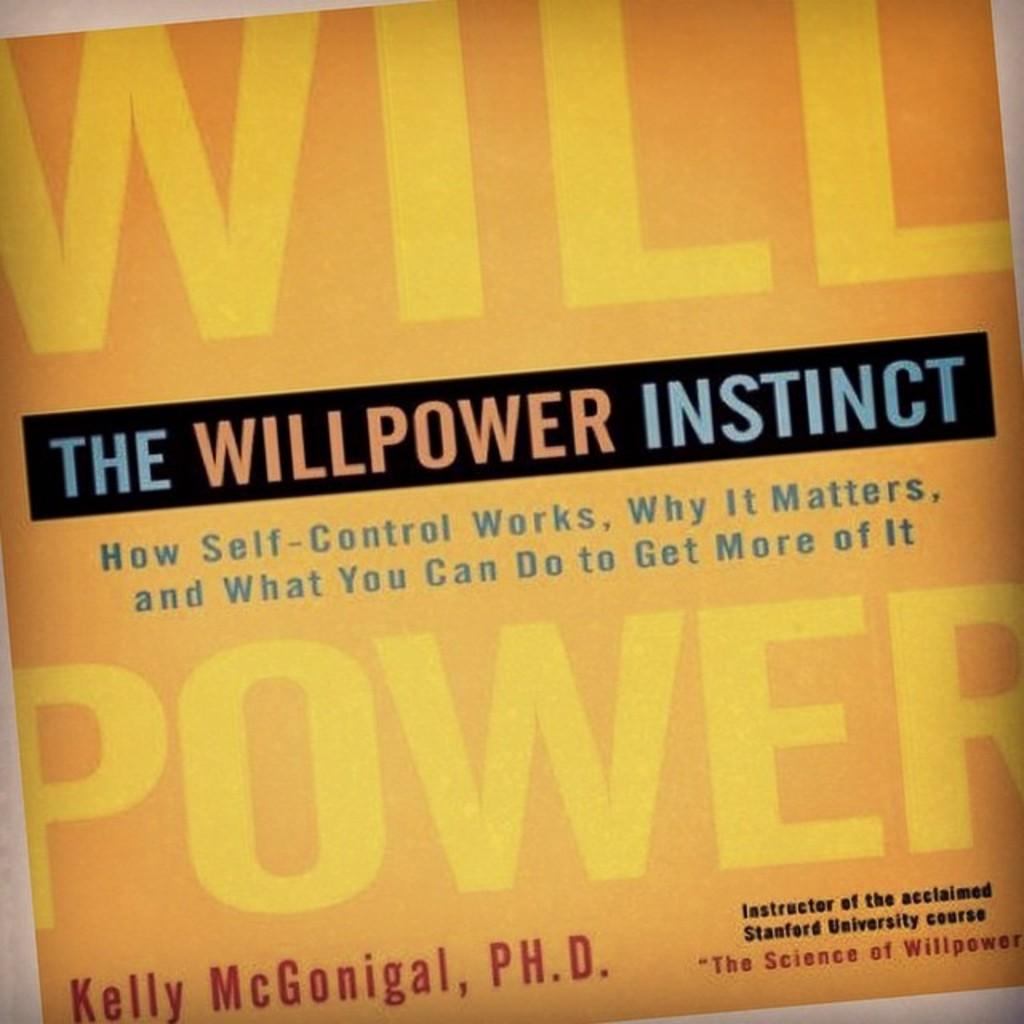What kind of instinct is mentioned?
Give a very brief answer. Willpower. Who wrote this book?
Your answer should be compact. Kelly mcgonigal. 